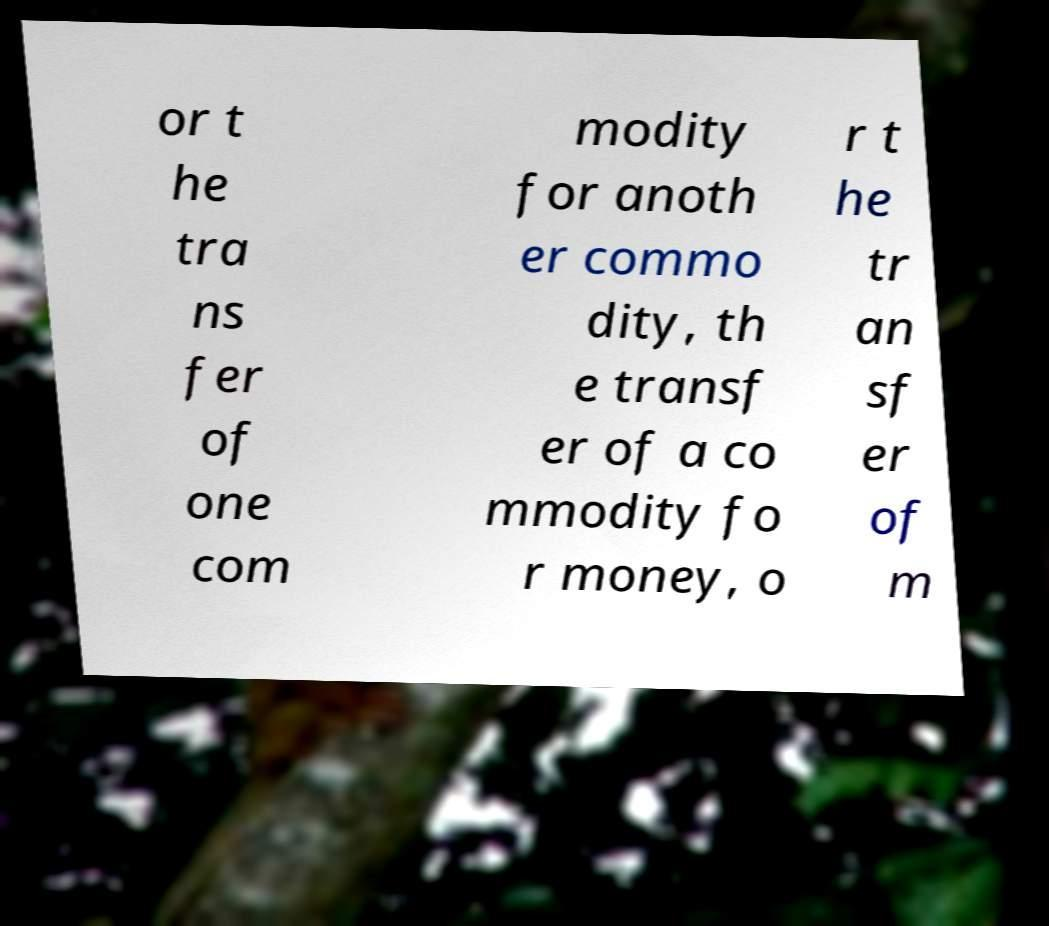There's text embedded in this image that I need extracted. Can you transcribe it verbatim? or t he tra ns fer of one com modity for anoth er commo dity, th e transf er of a co mmodity fo r money, o r t he tr an sf er of m 